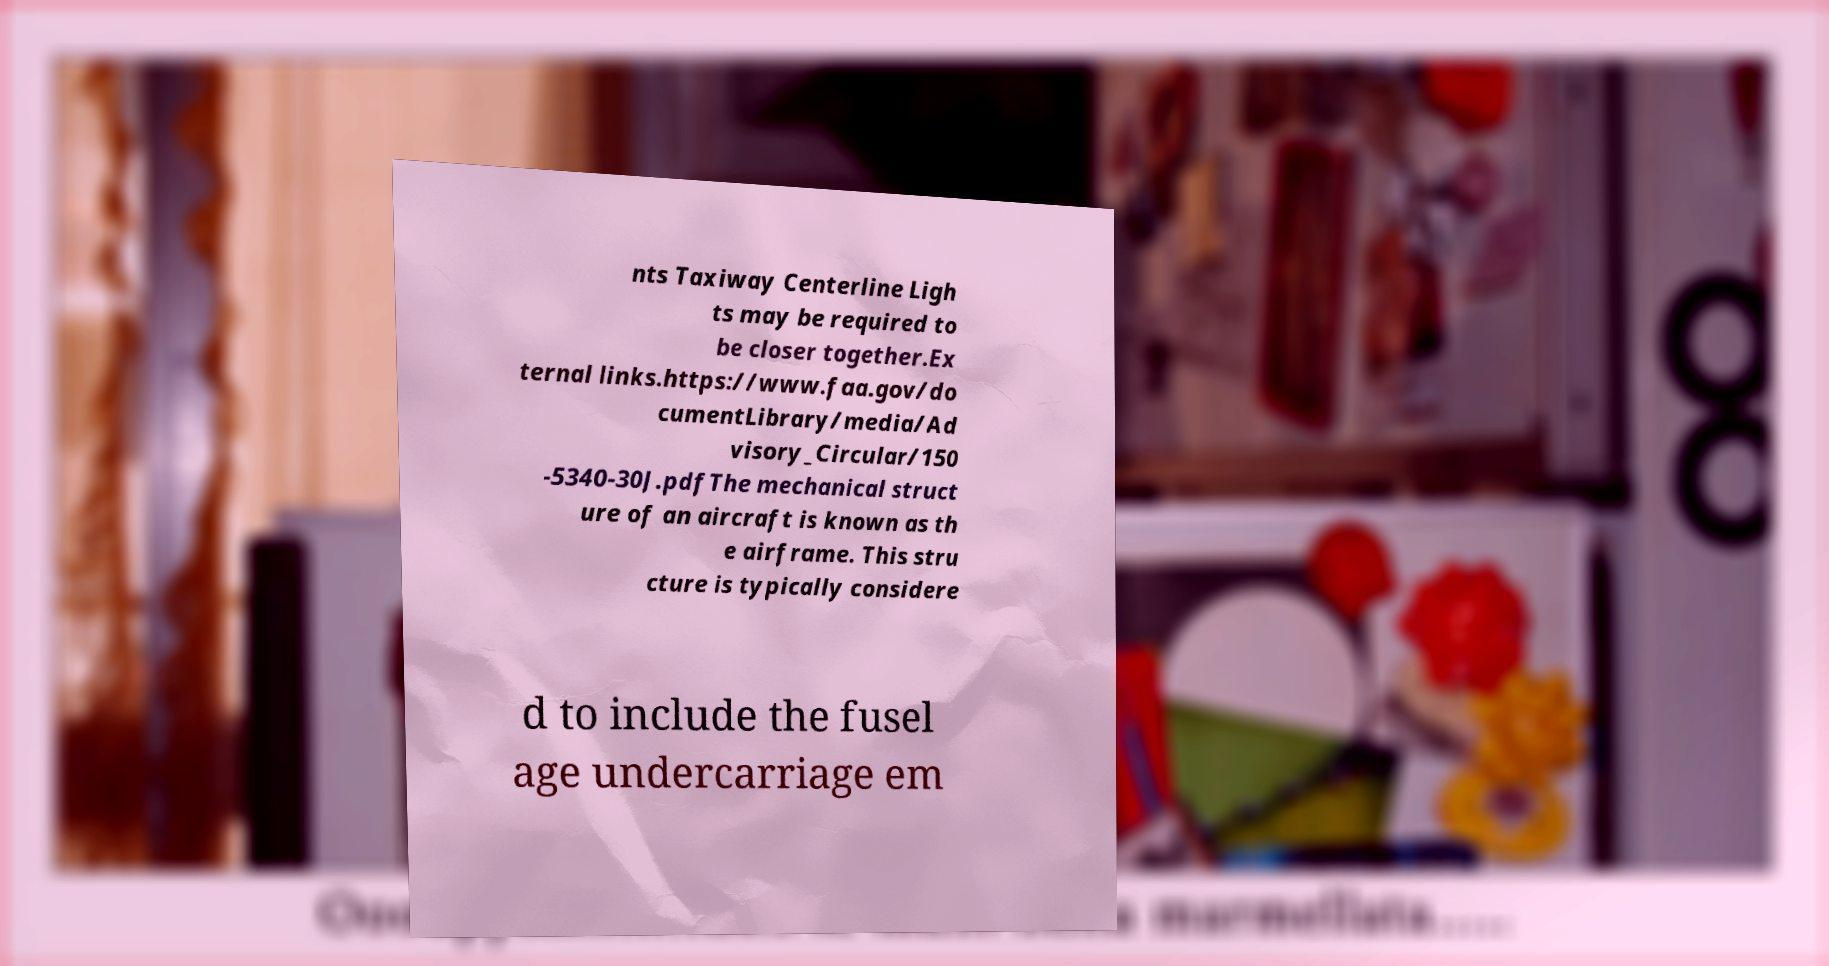For documentation purposes, I need the text within this image transcribed. Could you provide that? nts Taxiway Centerline Ligh ts may be required to be closer together.Ex ternal links.https://www.faa.gov/do cumentLibrary/media/Ad visory_Circular/150 -5340-30J.pdfThe mechanical struct ure of an aircraft is known as th e airframe. This stru cture is typically considere d to include the fusel age undercarriage em 